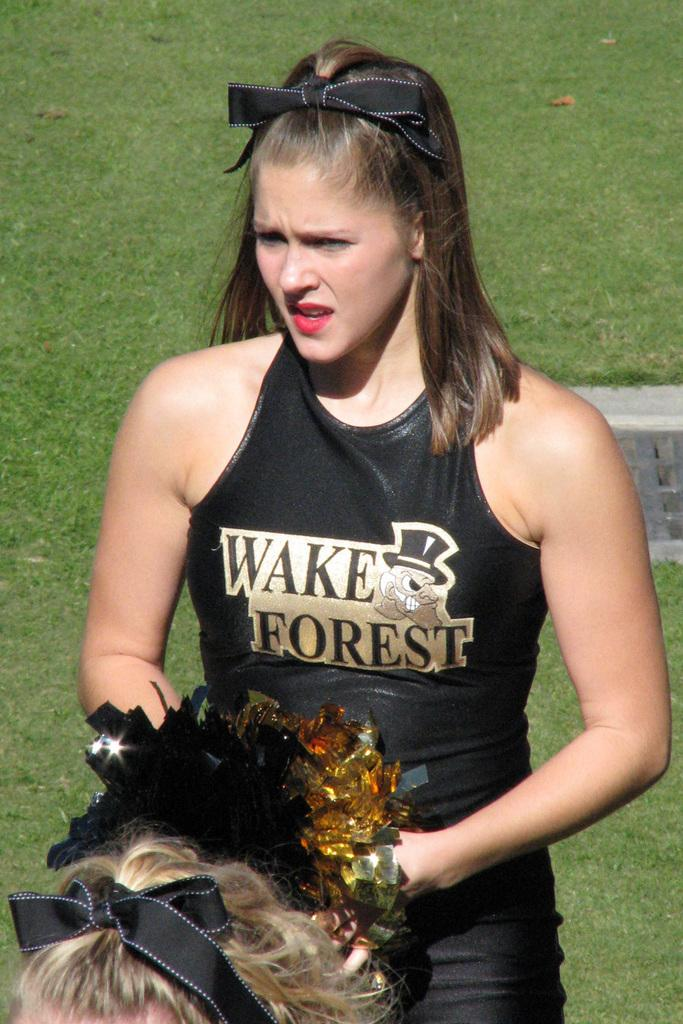<image>
Give a short and clear explanation of the subsequent image. a person that is wearing a Wake Forest outfit on the field 